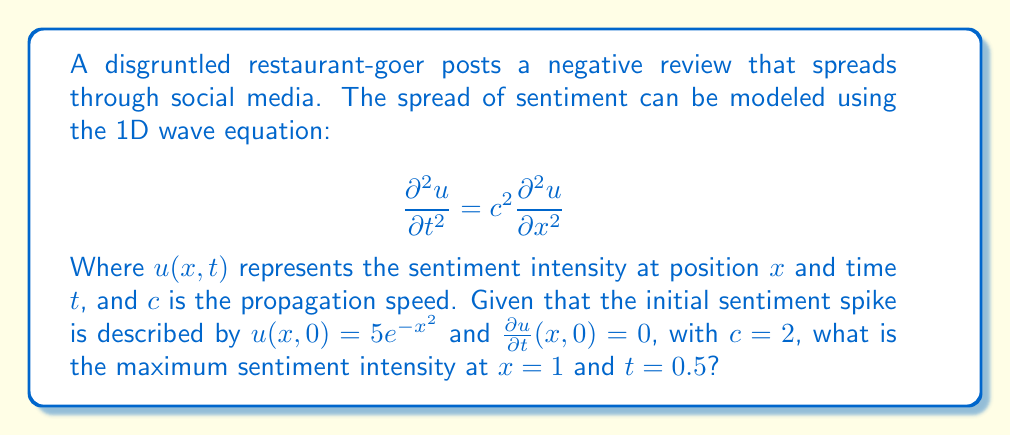Provide a solution to this math problem. To solve this problem, we'll use D'Alembert's solution for the 1D wave equation:

1) D'Alembert's solution is given by:
   $$u(x,t) = \frac{1}{2}[f(x+ct) + f(x-ct)] + \frac{1}{2c}\int_{x-ct}^{x+ct} g(s) ds$$

   Where $f(x) = u(x,0)$ and $g(x) = \frac{\partial u}{\partial t}(x,0)$

2) In our case:
   $f(x) = 5e^{-x^2}$
   $g(x) = 0$
   $c = 2$

3) Substituting these into D'Alembert's solution:
   $$u(x,t) = \frac{1}{2}[5e^{-(x+2t)^2} + 5e^{-(x-2t)^2}]$$

4) We need to find the maximum of this function at $x = 1$ and $t = 0.5$:
   $$u(1,0.5) = \frac{1}{2}[5e^{-(1+1)^2} + 5e^{-(1-1)^2}]$$
   $$= \frac{1}{2}[5e^{-4} + 5e^{0}]$$
   $$= \frac{1}{2}[5(0.0183) + 5]$$
   $$= 2.5457$$

5) This is the maximum sentiment intensity at the given point, as the wave equation solution gives us the exact value at any point in space and time.
Answer: 2.5457 